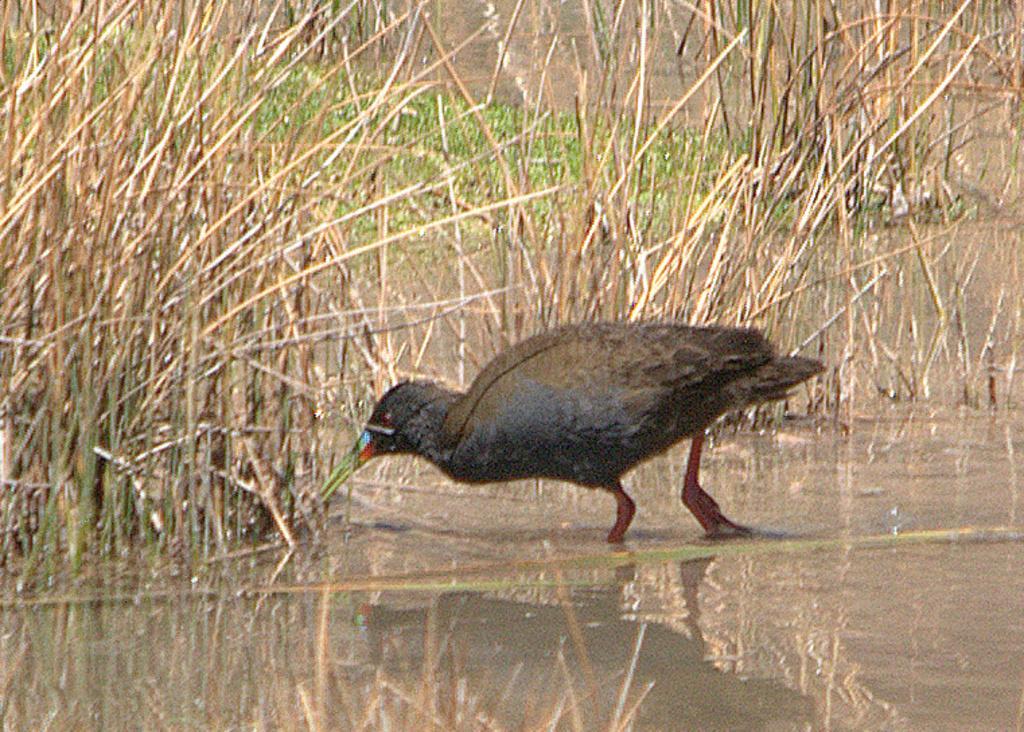Please provide a concise description of this image. In this we can see a black color bird in the water. Also there are plants in the water. 